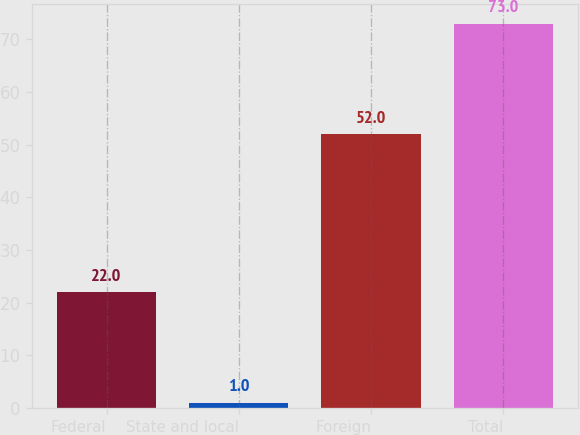Convert chart. <chart><loc_0><loc_0><loc_500><loc_500><bar_chart><fcel>Federal<fcel>State and local<fcel>Foreign<fcel>Total<nl><fcel>22<fcel>1<fcel>52<fcel>73<nl></chart> 